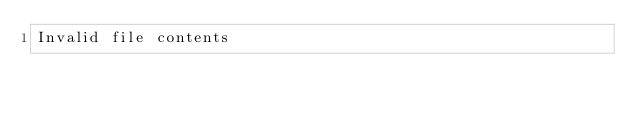<code> <loc_0><loc_0><loc_500><loc_500><_YAML_>Invalid file contents
</code> 